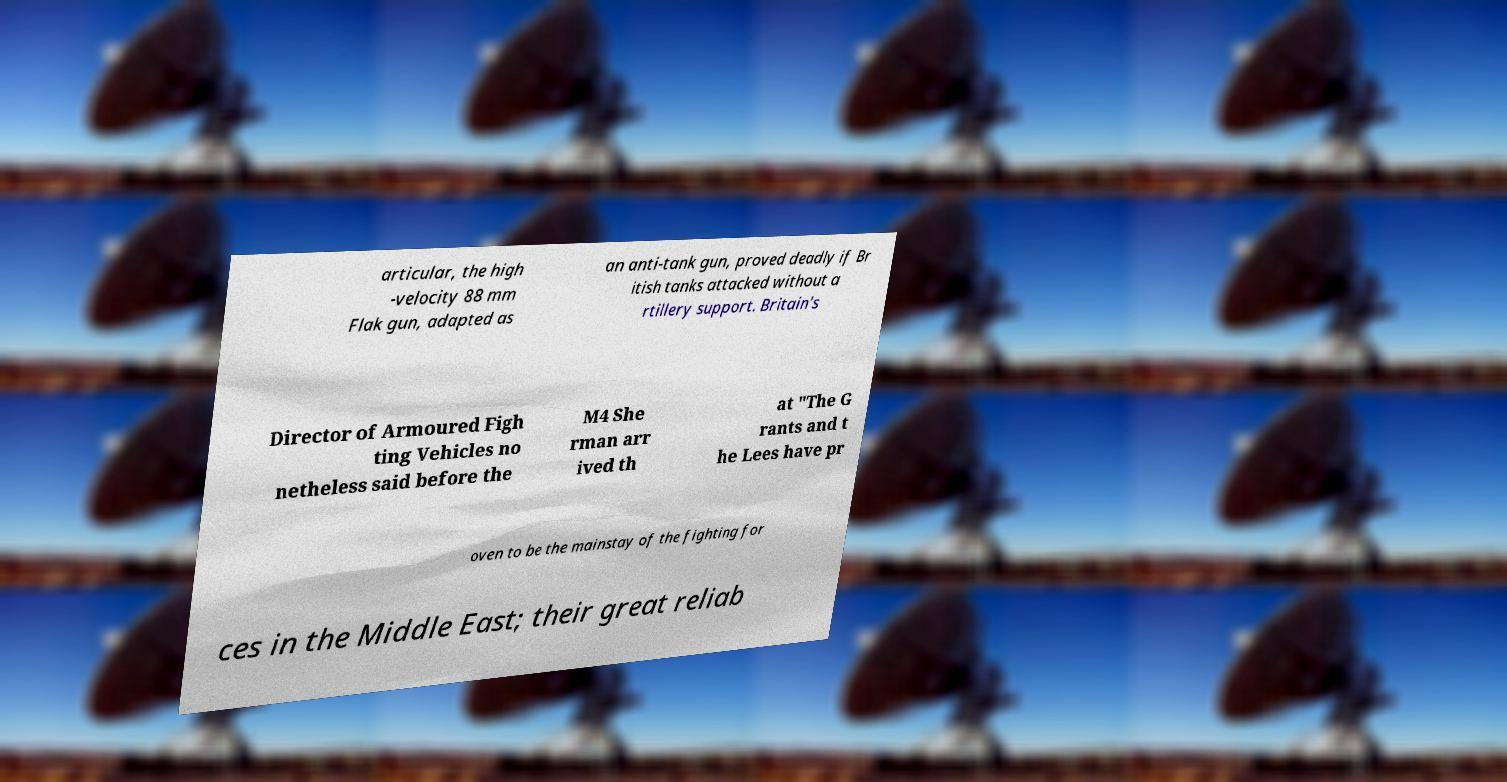What messages or text are displayed in this image? I need them in a readable, typed format. articular, the high -velocity 88 mm Flak gun, adapted as an anti-tank gun, proved deadly if Br itish tanks attacked without a rtillery support. Britain's Director of Armoured Figh ting Vehicles no netheless said before the M4 She rman arr ived th at "The G rants and t he Lees have pr oven to be the mainstay of the fighting for ces in the Middle East; their great reliab 